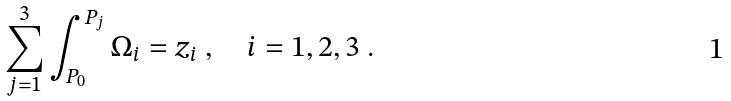<formula> <loc_0><loc_0><loc_500><loc_500>\sum _ { j = 1 } ^ { 3 } \int _ { P _ { 0 } } ^ { P _ { j } } \Omega _ { i } = z _ { i } \ , \quad i = 1 , 2 , 3 \ .</formula> 